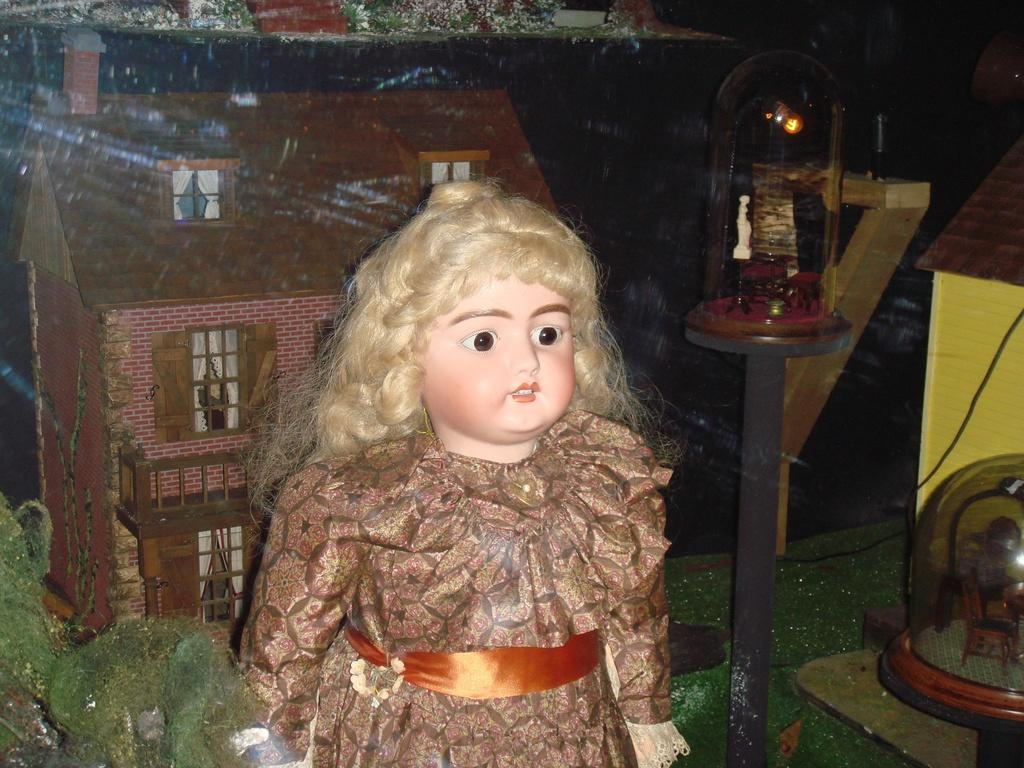What is the main subject of the picture? The main subject of the picture is a doll. What is unique about the doll in the picture? The doll has a cotton-made building on its back. Can you describe the lighting in the picture? There is a light on the right side of the picture. What type of hose can be seen connecting the doll to the building in the image? There is no hose present in the image; the doll has a cotton-made building on its back. How does the knot on the doll's back help in the image? There is no knot mentioned in the image; the doll has a cotton-made building on its back. 